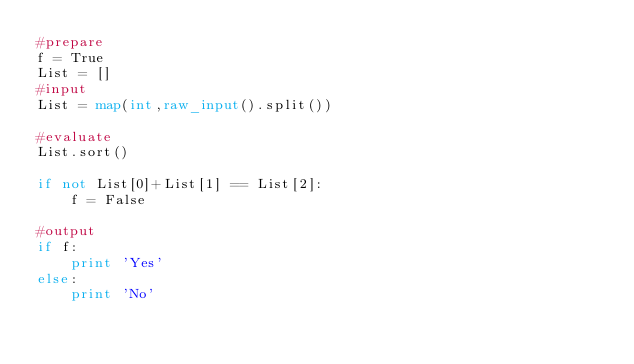<code> <loc_0><loc_0><loc_500><loc_500><_Python_>#prepare
f = True
List = []
#input
List = map(int,raw_input().split())

#evaluate
List.sort()

if not List[0]+List[1] == List[2]:
    f = False

#output
if f:
    print 'Yes'
else:
    print 'No'
</code> 